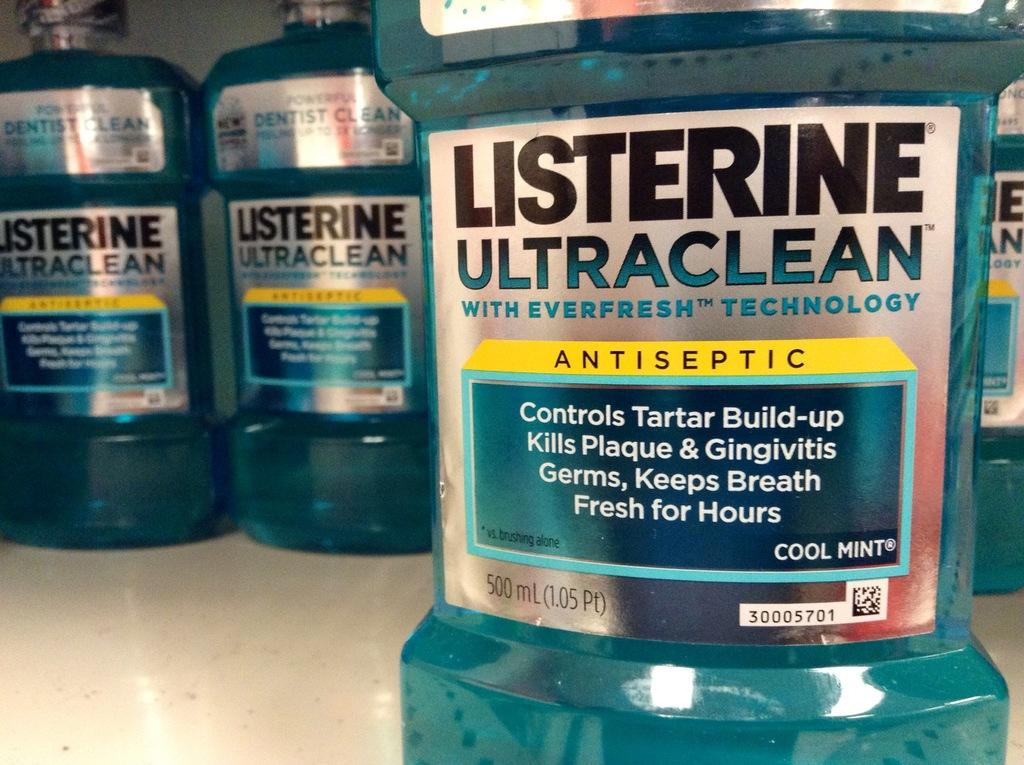<image>
Give a short and clear explanation of the subsequent image. Bottles of Listerine Ultraclean with everfresh technology antiseptic. 